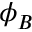Convert formula to latex. <formula><loc_0><loc_0><loc_500><loc_500>\phi _ { B }</formula> 